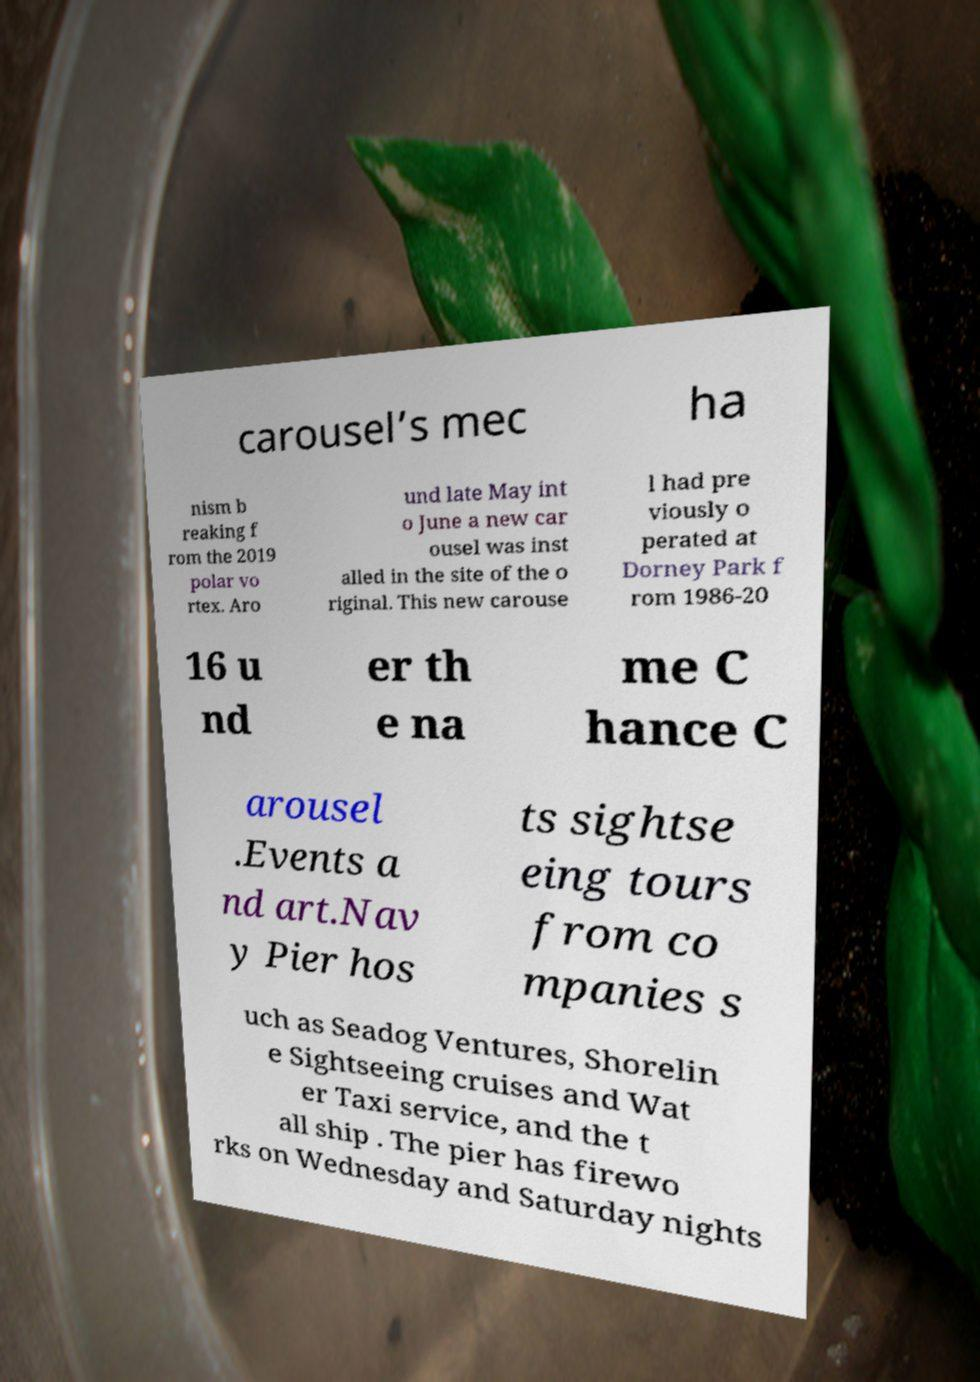Could you assist in decoding the text presented in this image and type it out clearly? carousel’s mec ha nism b reaking f rom the 2019 polar vo rtex. Aro und late May int o June a new car ousel was inst alled in the site of the o riginal. This new carouse l had pre viously o perated at Dorney Park f rom 1986-20 16 u nd er th e na me C hance C arousel .Events a nd art.Nav y Pier hos ts sightse eing tours from co mpanies s uch as Seadog Ventures, Shorelin e Sightseeing cruises and Wat er Taxi service, and the t all ship . The pier has firewo rks on Wednesday and Saturday nights 